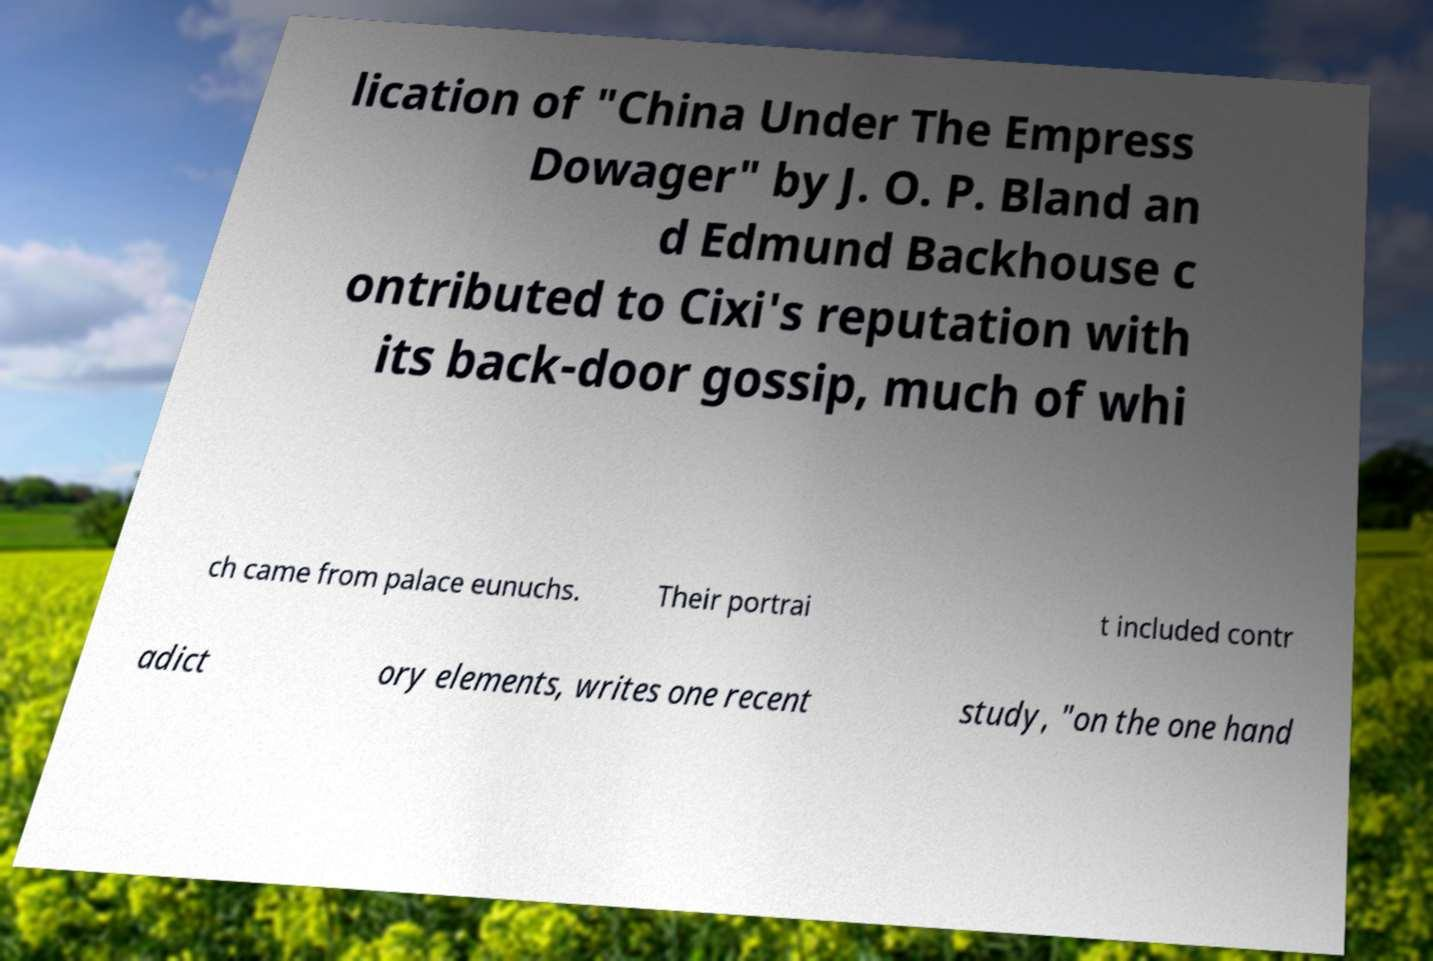Can you accurately transcribe the text from the provided image for me? lication of "China Under The Empress Dowager" by J. O. P. Bland an d Edmund Backhouse c ontributed to Cixi's reputation with its back-door gossip, much of whi ch came from palace eunuchs. Their portrai t included contr adict ory elements, writes one recent study, "on the one hand 